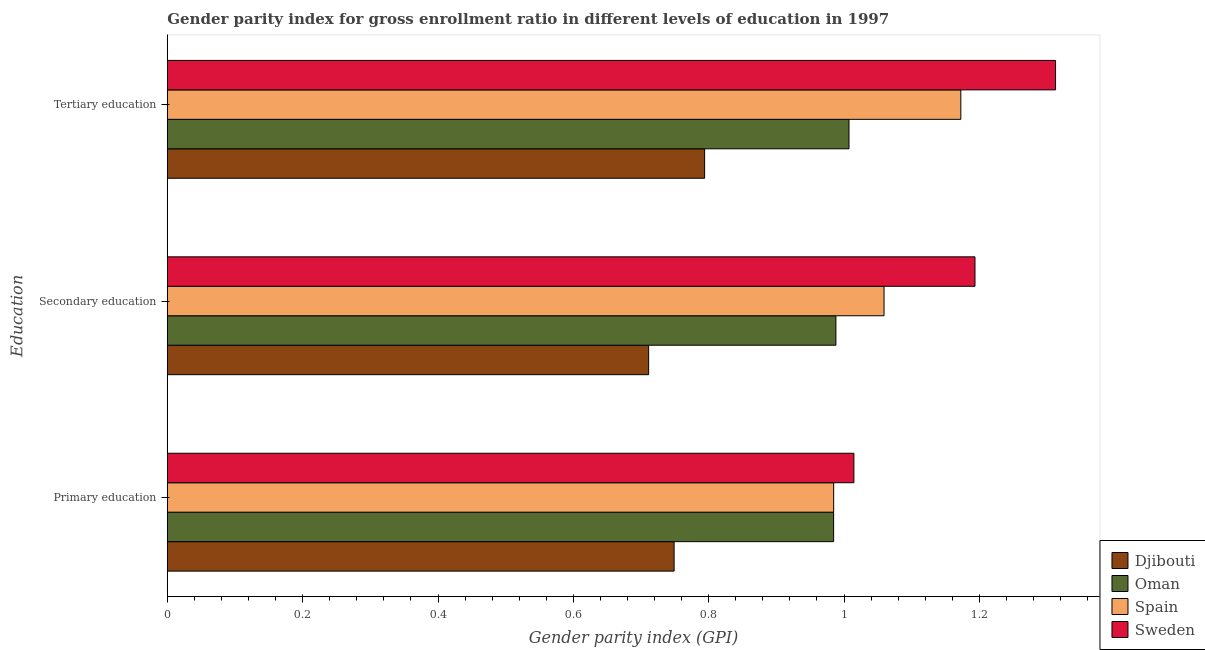Are the number of bars on each tick of the Y-axis equal?
Provide a short and direct response. Yes. What is the label of the 1st group of bars from the top?
Keep it short and to the point. Tertiary education. What is the gender parity index in secondary education in Oman?
Your answer should be very brief. 0.99. Across all countries, what is the maximum gender parity index in tertiary education?
Offer a very short reply. 1.31. Across all countries, what is the minimum gender parity index in secondary education?
Keep it short and to the point. 0.71. In which country was the gender parity index in tertiary education minimum?
Make the answer very short. Djibouti. What is the total gender parity index in secondary education in the graph?
Keep it short and to the point. 3.95. What is the difference between the gender parity index in primary education in Oman and that in Djibouti?
Offer a very short reply. 0.24. What is the difference between the gender parity index in primary education in Oman and the gender parity index in secondary education in Spain?
Keep it short and to the point. -0.07. What is the average gender parity index in primary education per country?
Give a very brief answer. 0.93. What is the difference between the gender parity index in primary education and gender parity index in secondary education in Oman?
Make the answer very short. -0. What is the ratio of the gender parity index in primary education in Oman to that in Sweden?
Offer a terse response. 0.97. Is the gender parity index in tertiary education in Spain less than that in Sweden?
Your answer should be very brief. Yes. Is the difference between the gender parity index in primary education in Sweden and Djibouti greater than the difference between the gender parity index in tertiary education in Sweden and Djibouti?
Offer a very short reply. No. What is the difference between the highest and the second highest gender parity index in primary education?
Your response must be concise. 0.03. What is the difference between the highest and the lowest gender parity index in tertiary education?
Make the answer very short. 0.52. In how many countries, is the gender parity index in primary education greater than the average gender parity index in primary education taken over all countries?
Your response must be concise. 3. Is the sum of the gender parity index in secondary education in Oman and Sweden greater than the maximum gender parity index in primary education across all countries?
Make the answer very short. Yes. What does the 4th bar from the top in Primary education represents?
Provide a short and direct response. Djibouti. Are all the bars in the graph horizontal?
Ensure brevity in your answer.  Yes. Does the graph contain any zero values?
Make the answer very short. No. Does the graph contain grids?
Offer a very short reply. No. Where does the legend appear in the graph?
Your response must be concise. Bottom right. How are the legend labels stacked?
Offer a terse response. Vertical. What is the title of the graph?
Your answer should be compact. Gender parity index for gross enrollment ratio in different levels of education in 1997. What is the label or title of the X-axis?
Offer a very short reply. Gender parity index (GPI). What is the label or title of the Y-axis?
Make the answer very short. Education. What is the Gender parity index (GPI) of Djibouti in Primary education?
Keep it short and to the point. 0.75. What is the Gender parity index (GPI) in Oman in Primary education?
Offer a terse response. 0.98. What is the Gender parity index (GPI) of Spain in Primary education?
Your answer should be very brief. 0.98. What is the Gender parity index (GPI) in Sweden in Primary education?
Offer a terse response. 1.01. What is the Gender parity index (GPI) of Djibouti in Secondary education?
Your answer should be very brief. 0.71. What is the Gender parity index (GPI) in Oman in Secondary education?
Your answer should be compact. 0.99. What is the Gender parity index (GPI) in Spain in Secondary education?
Offer a very short reply. 1.06. What is the Gender parity index (GPI) of Sweden in Secondary education?
Your answer should be very brief. 1.19. What is the Gender parity index (GPI) of Djibouti in Tertiary education?
Provide a short and direct response. 0.79. What is the Gender parity index (GPI) of Oman in Tertiary education?
Provide a short and direct response. 1.01. What is the Gender parity index (GPI) in Spain in Tertiary education?
Give a very brief answer. 1.17. What is the Gender parity index (GPI) of Sweden in Tertiary education?
Your response must be concise. 1.31. Across all Education, what is the maximum Gender parity index (GPI) of Djibouti?
Offer a very short reply. 0.79. Across all Education, what is the maximum Gender parity index (GPI) of Oman?
Make the answer very short. 1.01. Across all Education, what is the maximum Gender parity index (GPI) in Spain?
Provide a succinct answer. 1.17. Across all Education, what is the maximum Gender parity index (GPI) in Sweden?
Your answer should be compact. 1.31. Across all Education, what is the minimum Gender parity index (GPI) in Djibouti?
Offer a very short reply. 0.71. Across all Education, what is the minimum Gender parity index (GPI) of Oman?
Your response must be concise. 0.98. Across all Education, what is the minimum Gender parity index (GPI) of Spain?
Offer a terse response. 0.98. Across all Education, what is the minimum Gender parity index (GPI) of Sweden?
Offer a very short reply. 1.01. What is the total Gender parity index (GPI) in Djibouti in the graph?
Your answer should be compact. 2.25. What is the total Gender parity index (GPI) in Oman in the graph?
Offer a terse response. 2.98. What is the total Gender parity index (GPI) in Spain in the graph?
Give a very brief answer. 3.22. What is the total Gender parity index (GPI) in Sweden in the graph?
Your answer should be compact. 3.52. What is the difference between the Gender parity index (GPI) in Djibouti in Primary education and that in Secondary education?
Make the answer very short. 0.04. What is the difference between the Gender parity index (GPI) in Oman in Primary education and that in Secondary education?
Provide a short and direct response. -0. What is the difference between the Gender parity index (GPI) of Spain in Primary education and that in Secondary education?
Provide a succinct answer. -0.07. What is the difference between the Gender parity index (GPI) in Sweden in Primary education and that in Secondary education?
Your answer should be compact. -0.18. What is the difference between the Gender parity index (GPI) in Djibouti in Primary education and that in Tertiary education?
Your response must be concise. -0.05. What is the difference between the Gender parity index (GPI) of Oman in Primary education and that in Tertiary education?
Give a very brief answer. -0.02. What is the difference between the Gender parity index (GPI) in Spain in Primary education and that in Tertiary education?
Give a very brief answer. -0.19. What is the difference between the Gender parity index (GPI) in Sweden in Primary education and that in Tertiary education?
Give a very brief answer. -0.3. What is the difference between the Gender parity index (GPI) in Djibouti in Secondary education and that in Tertiary education?
Make the answer very short. -0.08. What is the difference between the Gender parity index (GPI) in Oman in Secondary education and that in Tertiary education?
Your response must be concise. -0.02. What is the difference between the Gender parity index (GPI) of Spain in Secondary education and that in Tertiary education?
Your response must be concise. -0.11. What is the difference between the Gender parity index (GPI) of Sweden in Secondary education and that in Tertiary education?
Provide a short and direct response. -0.12. What is the difference between the Gender parity index (GPI) in Djibouti in Primary education and the Gender parity index (GPI) in Oman in Secondary education?
Give a very brief answer. -0.24. What is the difference between the Gender parity index (GPI) of Djibouti in Primary education and the Gender parity index (GPI) of Spain in Secondary education?
Your answer should be very brief. -0.31. What is the difference between the Gender parity index (GPI) in Djibouti in Primary education and the Gender parity index (GPI) in Sweden in Secondary education?
Keep it short and to the point. -0.44. What is the difference between the Gender parity index (GPI) of Oman in Primary education and the Gender parity index (GPI) of Spain in Secondary education?
Offer a terse response. -0.07. What is the difference between the Gender parity index (GPI) of Oman in Primary education and the Gender parity index (GPI) of Sweden in Secondary education?
Ensure brevity in your answer.  -0.21. What is the difference between the Gender parity index (GPI) of Spain in Primary education and the Gender parity index (GPI) of Sweden in Secondary education?
Keep it short and to the point. -0.21. What is the difference between the Gender parity index (GPI) in Djibouti in Primary education and the Gender parity index (GPI) in Oman in Tertiary education?
Your answer should be very brief. -0.26. What is the difference between the Gender parity index (GPI) of Djibouti in Primary education and the Gender parity index (GPI) of Spain in Tertiary education?
Make the answer very short. -0.42. What is the difference between the Gender parity index (GPI) of Djibouti in Primary education and the Gender parity index (GPI) of Sweden in Tertiary education?
Give a very brief answer. -0.56. What is the difference between the Gender parity index (GPI) in Oman in Primary education and the Gender parity index (GPI) in Spain in Tertiary education?
Provide a short and direct response. -0.19. What is the difference between the Gender parity index (GPI) of Oman in Primary education and the Gender parity index (GPI) of Sweden in Tertiary education?
Your answer should be very brief. -0.33. What is the difference between the Gender parity index (GPI) of Spain in Primary education and the Gender parity index (GPI) of Sweden in Tertiary education?
Provide a succinct answer. -0.33. What is the difference between the Gender parity index (GPI) of Djibouti in Secondary education and the Gender parity index (GPI) of Oman in Tertiary education?
Your answer should be very brief. -0.3. What is the difference between the Gender parity index (GPI) of Djibouti in Secondary education and the Gender parity index (GPI) of Spain in Tertiary education?
Provide a succinct answer. -0.46. What is the difference between the Gender parity index (GPI) in Djibouti in Secondary education and the Gender parity index (GPI) in Sweden in Tertiary education?
Make the answer very short. -0.6. What is the difference between the Gender parity index (GPI) in Oman in Secondary education and the Gender parity index (GPI) in Spain in Tertiary education?
Give a very brief answer. -0.18. What is the difference between the Gender parity index (GPI) in Oman in Secondary education and the Gender parity index (GPI) in Sweden in Tertiary education?
Ensure brevity in your answer.  -0.32. What is the difference between the Gender parity index (GPI) of Spain in Secondary education and the Gender parity index (GPI) of Sweden in Tertiary education?
Make the answer very short. -0.25. What is the average Gender parity index (GPI) of Djibouti per Education?
Provide a short and direct response. 0.75. What is the average Gender parity index (GPI) of Oman per Education?
Your answer should be very brief. 0.99. What is the average Gender parity index (GPI) in Spain per Education?
Your answer should be very brief. 1.07. What is the average Gender parity index (GPI) in Sweden per Education?
Your answer should be very brief. 1.17. What is the difference between the Gender parity index (GPI) of Djibouti and Gender parity index (GPI) of Oman in Primary education?
Provide a short and direct response. -0.24. What is the difference between the Gender parity index (GPI) of Djibouti and Gender parity index (GPI) of Spain in Primary education?
Your answer should be compact. -0.24. What is the difference between the Gender parity index (GPI) of Djibouti and Gender parity index (GPI) of Sweden in Primary education?
Ensure brevity in your answer.  -0.27. What is the difference between the Gender parity index (GPI) in Oman and Gender parity index (GPI) in Spain in Primary education?
Offer a terse response. -0. What is the difference between the Gender parity index (GPI) of Oman and Gender parity index (GPI) of Sweden in Primary education?
Your answer should be compact. -0.03. What is the difference between the Gender parity index (GPI) in Spain and Gender parity index (GPI) in Sweden in Primary education?
Provide a succinct answer. -0.03. What is the difference between the Gender parity index (GPI) of Djibouti and Gender parity index (GPI) of Oman in Secondary education?
Provide a short and direct response. -0.28. What is the difference between the Gender parity index (GPI) of Djibouti and Gender parity index (GPI) of Spain in Secondary education?
Offer a terse response. -0.35. What is the difference between the Gender parity index (GPI) in Djibouti and Gender parity index (GPI) in Sweden in Secondary education?
Make the answer very short. -0.48. What is the difference between the Gender parity index (GPI) of Oman and Gender parity index (GPI) of Spain in Secondary education?
Keep it short and to the point. -0.07. What is the difference between the Gender parity index (GPI) of Oman and Gender parity index (GPI) of Sweden in Secondary education?
Offer a terse response. -0.21. What is the difference between the Gender parity index (GPI) of Spain and Gender parity index (GPI) of Sweden in Secondary education?
Offer a very short reply. -0.13. What is the difference between the Gender parity index (GPI) of Djibouti and Gender parity index (GPI) of Oman in Tertiary education?
Make the answer very short. -0.21. What is the difference between the Gender parity index (GPI) of Djibouti and Gender parity index (GPI) of Spain in Tertiary education?
Provide a short and direct response. -0.38. What is the difference between the Gender parity index (GPI) in Djibouti and Gender parity index (GPI) in Sweden in Tertiary education?
Keep it short and to the point. -0.52. What is the difference between the Gender parity index (GPI) in Oman and Gender parity index (GPI) in Spain in Tertiary education?
Your answer should be very brief. -0.17. What is the difference between the Gender parity index (GPI) of Oman and Gender parity index (GPI) of Sweden in Tertiary education?
Ensure brevity in your answer.  -0.31. What is the difference between the Gender parity index (GPI) in Spain and Gender parity index (GPI) in Sweden in Tertiary education?
Your answer should be compact. -0.14. What is the ratio of the Gender parity index (GPI) of Djibouti in Primary education to that in Secondary education?
Your answer should be compact. 1.05. What is the ratio of the Gender parity index (GPI) in Spain in Primary education to that in Secondary education?
Your response must be concise. 0.93. What is the ratio of the Gender parity index (GPI) of Sweden in Primary education to that in Secondary education?
Your answer should be compact. 0.85. What is the ratio of the Gender parity index (GPI) in Djibouti in Primary education to that in Tertiary education?
Provide a short and direct response. 0.94. What is the ratio of the Gender parity index (GPI) in Oman in Primary education to that in Tertiary education?
Your answer should be very brief. 0.98. What is the ratio of the Gender parity index (GPI) in Spain in Primary education to that in Tertiary education?
Provide a short and direct response. 0.84. What is the ratio of the Gender parity index (GPI) of Sweden in Primary education to that in Tertiary education?
Keep it short and to the point. 0.77. What is the ratio of the Gender parity index (GPI) in Djibouti in Secondary education to that in Tertiary education?
Keep it short and to the point. 0.9. What is the ratio of the Gender parity index (GPI) of Oman in Secondary education to that in Tertiary education?
Your answer should be compact. 0.98. What is the ratio of the Gender parity index (GPI) of Spain in Secondary education to that in Tertiary education?
Keep it short and to the point. 0.9. What is the ratio of the Gender parity index (GPI) in Sweden in Secondary education to that in Tertiary education?
Offer a terse response. 0.91. What is the difference between the highest and the second highest Gender parity index (GPI) of Djibouti?
Ensure brevity in your answer.  0.05. What is the difference between the highest and the second highest Gender parity index (GPI) in Oman?
Provide a short and direct response. 0.02. What is the difference between the highest and the second highest Gender parity index (GPI) in Spain?
Your response must be concise. 0.11. What is the difference between the highest and the second highest Gender parity index (GPI) of Sweden?
Offer a terse response. 0.12. What is the difference between the highest and the lowest Gender parity index (GPI) in Djibouti?
Your response must be concise. 0.08. What is the difference between the highest and the lowest Gender parity index (GPI) in Oman?
Give a very brief answer. 0.02. What is the difference between the highest and the lowest Gender parity index (GPI) in Spain?
Your response must be concise. 0.19. What is the difference between the highest and the lowest Gender parity index (GPI) in Sweden?
Offer a very short reply. 0.3. 